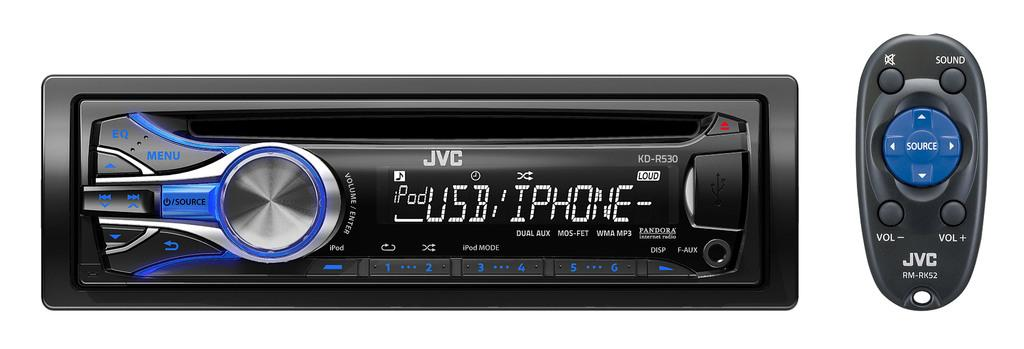<image>
Give a short and clear explanation of the subsequent image. the jvc radio connects to phone and usb 